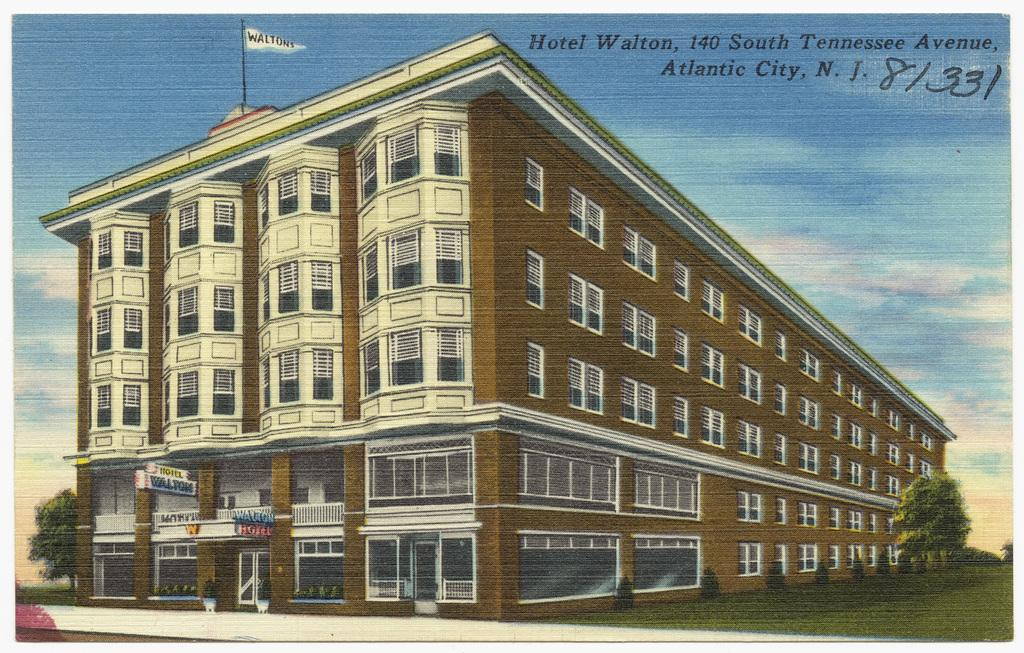What type of image is being described? The image is graphical in nature. What structure can be seen in the image? There is a building in the image. What type of vegetation is present in the image? There are trees and grass in the image. What can be seen in the sky in the image? There are clouds in the sky in the image. What part of the sky is visible in the image? The sky is visible in the image. What type of tray is being used to hold the clouds in the image? There is no tray present in the image; the clouds are naturally in the sky. 